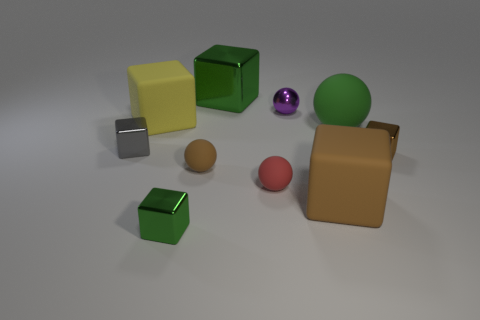Is there any other thing of the same color as the large matte ball?
Your answer should be very brief. Yes. There is a green thing in front of the tiny brown cube; does it have the same shape as the brown shiny object?
Make the answer very short. Yes. What material is the large ball?
Your answer should be very brief. Rubber. What shape is the tiny metallic thing that is on the left side of the green shiny thing in front of the metal object that is left of the big yellow matte thing?
Provide a succinct answer. Cube. What number of other things are the same shape as the purple thing?
Offer a terse response. 3. There is a big shiny thing; is its color the same as the shiny cube that is right of the small purple object?
Your response must be concise. No. What number of tiny yellow objects are there?
Ensure brevity in your answer.  0. What number of things are either tiny brown cylinders or tiny things?
Your response must be concise. 6. There is another shiny block that is the same color as the large metal block; what is its size?
Your response must be concise. Small. There is a tiny purple metal object; are there any small things to the right of it?
Your answer should be very brief. Yes. 